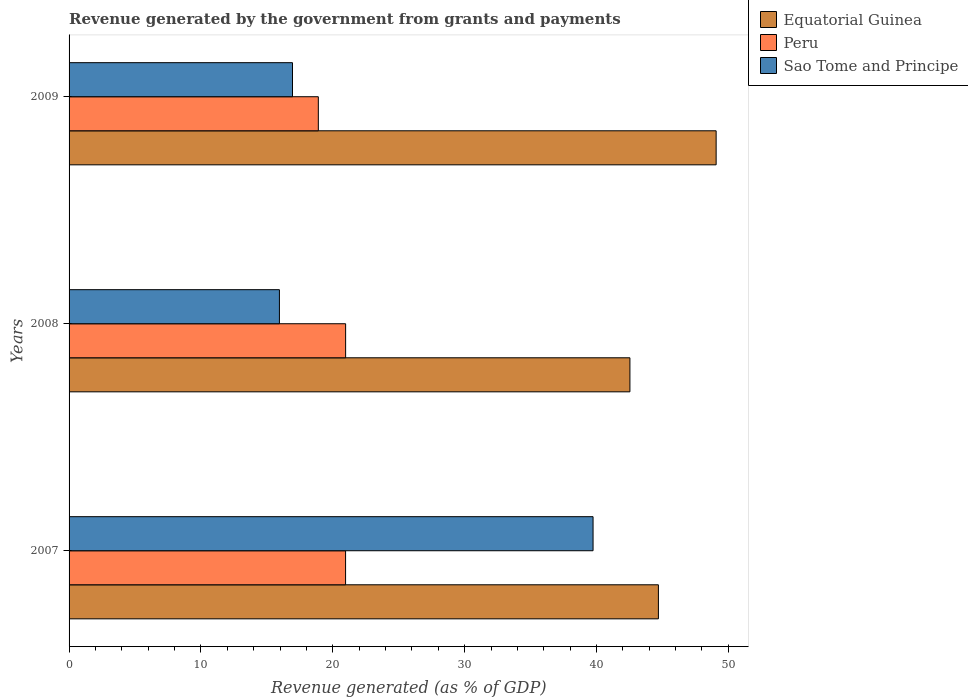Are the number of bars per tick equal to the number of legend labels?
Your answer should be very brief. Yes. How many bars are there on the 2nd tick from the top?
Offer a very short reply. 3. How many bars are there on the 2nd tick from the bottom?
Keep it short and to the point. 3. In how many cases, is the number of bars for a given year not equal to the number of legend labels?
Provide a short and direct response. 0. What is the revenue generated by the government in Equatorial Guinea in 2008?
Your answer should be very brief. 42.54. Across all years, what is the maximum revenue generated by the government in Equatorial Guinea?
Offer a very short reply. 49.07. Across all years, what is the minimum revenue generated by the government in Peru?
Ensure brevity in your answer.  18.9. In which year was the revenue generated by the government in Sao Tome and Principe minimum?
Keep it short and to the point. 2008. What is the total revenue generated by the government in Peru in the graph?
Your answer should be compact. 60.85. What is the difference between the revenue generated by the government in Sao Tome and Principe in 2008 and that in 2009?
Your response must be concise. -0.99. What is the difference between the revenue generated by the government in Peru in 2009 and the revenue generated by the government in Equatorial Guinea in 2007?
Your response must be concise. -25.79. What is the average revenue generated by the government in Sao Tome and Principe per year?
Ensure brevity in your answer.  24.21. In the year 2007, what is the difference between the revenue generated by the government in Peru and revenue generated by the government in Sao Tome and Principe?
Provide a succinct answer. -18.77. In how many years, is the revenue generated by the government in Equatorial Guinea greater than 46 %?
Your answer should be very brief. 1. What is the ratio of the revenue generated by the government in Peru in 2007 to that in 2008?
Your answer should be very brief. 1. Is the difference between the revenue generated by the government in Peru in 2008 and 2009 greater than the difference between the revenue generated by the government in Sao Tome and Principe in 2008 and 2009?
Your response must be concise. Yes. What is the difference between the highest and the second highest revenue generated by the government in Equatorial Guinea?
Your answer should be very brief. 4.38. What is the difference between the highest and the lowest revenue generated by the government in Sao Tome and Principe?
Your response must be concise. 23.79. What does the 1st bar from the top in 2009 represents?
Your answer should be compact. Sao Tome and Principe. How many bars are there?
Offer a very short reply. 9. Are all the bars in the graph horizontal?
Offer a terse response. Yes. How many years are there in the graph?
Your response must be concise. 3. Are the values on the major ticks of X-axis written in scientific E-notation?
Your answer should be very brief. No. Where does the legend appear in the graph?
Your answer should be compact. Top right. How are the legend labels stacked?
Your response must be concise. Vertical. What is the title of the graph?
Your response must be concise. Revenue generated by the government from grants and payments. What is the label or title of the X-axis?
Keep it short and to the point. Revenue generated (as % of GDP). What is the label or title of the Y-axis?
Make the answer very short. Years. What is the Revenue generated (as % of GDP) in Equatorial Guinea in 2007?
Give a very brief answer. 44.7. What is the Revenue generated (as % of GDP) of Peru in 2007?
Provide a succinct answer. 20.97. What is the Revenue generated (as % of GDP) of Sao Tome and Principe in 2007?
Provide a short and direct response. 39.74. What is the Revenue generated (as % of GDP) in Equatorial Guinea in 2008?
Make the answer very short. 42.54. What is the Revenue generated (as % of GDP) of Peru in 2008?
Offer a very short reply. 20.97. What is the Revenue generated (as % of GDP) in Sao Tome and Principe in 2008?
Your answer should be compact. 15.95. What is the Revenue generated (as % of GDP) of Equatorial Guinea in 2009?
Provide a short and direct response. 49.07. What is the Revenue generated (as % of GDP) in Peru in 2009?
Your answer should be compact. 18.9. What is the Revenue generated (as % of GDP) in Sao Tome and Principe in 2009?
Give a very brief answer. 16.95. Across all years, what is the maximum Revenue generated (as % of GDP) in Equatorial Guinea?
Offer a terse response. 49.07. Across all years, what is the maximum Revenue generated (as % of GDP) of Peru?
Make the answer very short. 20.97. Across all years, what is the maximum Revenue generated (as % of GDP) of Sao Tome and Principe?
Your answer should be very brief. 39.74. Across all years, what is the minimum Revenue generated (as % of GDP) of Equatorial Guinea?
Give a very brief answer. 42.54. Across all years, what is the minimum Revenue generated (as % of GDP) in Peru?
Your answer should be very brief. 18.9. Across all years, what is the minimum Revenue generated (as % of GDP) of Sao Tome and Principe?
Offer a terse response. 15.95. What is the total Revenue generated (as % of GDP) in Equatorial Guinea in the graph?
Your response must be concise. 136.31. What is the total Revenue generated (as % of GDP) in Peru in the graph?
Ensure brevity in your answer.  60.85. What is the total Revenue generated (as % of GDP) in Sao Tome and Principe in the graph?
Offer a very short reply. 72.64. What is the difference between the Revenue generated (as % of GDP) of Equatorial Guinea in 2007 and that in 2008?
Keep it short and to the point. 2.16. What is the difference between the Revenue generated (as % of GDP) of Peru in 2007 and that in 2008?
Make the answer very short. -0. What is the difference between the Revenue generated (as % of GDP) in Sao Tome and Principe in 2007 and that in 2008?
Offer a terse response. 23.79. What is the difference between the Revenue generated (as % of GDP) in Equatorial Guinea in 2007 and that in 2009?
Give a very brief answer. -4.38. What is the difference between the Revenue generated (as % of GDP) of Peru in 2007 and that in 2009?
Provide a short and direct response. 2.07. What is the difference between the Revenue generated (as % of GDP) of Sao Tome and Principe in 2007 and that in 2009?
Give a very brief answer. 22.79. What is the difference between the Revenue generated (as % of GDP) of Equatorial Guinea in 2008 and that in 2009?
Your answer should be very brief. -6.54. What is the difference between the Revenue generated (as % of GDP) in Peru in 2008 and that in 2009?
Provide a short and direct response. 2.07. What is the difference between the Revenue generated (as % of GDP) in Sao Tome and Principe in 2008 and that in 2009?
Make the answer very short. -0.99. What is the difference between the Revenue generated (as % of GDP) in Equatorial Guinea in 2007 and the Revenue generated (as % of GDP) in Peru in 2008?
Make the answer very short. 23.72. What is the difference between the Revenue generated (as % of GDP) of Equatorial Guinea in 2007 and the Revenue generated (as % of GDP) of Sao Tome and Principe in 2008?
Ensure brevity in your answer.  28.74. What is the difference between the Revenue generated (as % of GDP) of Peru in 2007 and the Revenue generated (as % of GDP) of Sao Tome and Principe in 2008?
Ensure brevity in your answer.  5.02. What is the difference between the Revenue generated (as % of GDP) in Equatorial Guinea in 2007 and the Revenue generated (as % of GDP) in Peru in 2009?
Give a very brief answer. 25.79. What is the difference between the Revenue generated (as % of GDP) of Equatorial Guinea in 2007 and the Revenue generated (as % of GDP) of Sao Tome and Principe in 2009?
Your response must be concise. 27.75. What is the difference between the Revenue generated (as % of GDP) of Peru in 2007 and the Revenue generated (as % of GDP) of Sao Tome and Principe in 2009?
Your answer should be compact. 4.03. What is the difference between the Revenue generated (as % of GDP) in Equatorial Guinea in 2008 and the Revenue generated (as % of GDP) in Peru in 2009?
Your answer should be very brief. 23.63. What is the difference between the Revenue generated (as % of GDP) of Equatorial Guinea in 2008 and the Revenue generated (as % of GDP) of Sao Tome and Principe in 2009?
Your answer should be very brief. 25.59. What is the difference between the Revenue generated (as % of GDP) in Peru in 2008 and the Revenue generated (as % of GDP) in Sao Tome and Principe in 2009?
Ensure brevity in your answer.  4.03. What is the average Revenue generated (as % of GDP) of Equatorial Guinea per year?
Provide a short and direct response. 45.44. What is the average Revenue generated (as % of GDP) of Peru per year?
Provide a succinct answer. 20.28. What is the average Revenue generated (as % of GDP) in Sao Tome and Principe per year?
Provide a short and direct response. 24.21. In the year 2007, what is the difference between the Revenue generated (as % of GDP) in Equatorial Guinea and Revenue generated (as % of GDP) in Peru?
Your answer should be compact. 23.73. In the year 2007, what is the difference between the Revenue generated (as % of GDP) in Equatorial Guinea and Revenue generated (as % of GDP) in Sao Tome and Principe?
Give a very brief answer. 4.96. In the year 2007, what is the difference between the Revenue generated (as % of GDP) in Peru and Revenue generated (as % of GDP) in Sao Tome and Principe?
Your answer should be very brief. -18.77. In the year 2008, what is the difference between the Revenue generated (as % of GDP) of Equatorial Guinea and Revenue generated (as % of GDP) of Peru?
Provide a short and direct response. 21.56. In the year 2008, what is the difference between the Revenue generated (as % of GDP) in Equatorial Guinea and Revenue generated (as % of GDP) in Sao Tome and Principe?
Your answer should be compact. 26.58. In the year 2008, what is the difference between the Revenue generated (as % of GDP) in Peru and Revenue generated (as % of GDP) in Sao Tome and Principe?
Ensure brevity in your answer.  5.02. In the year 2009, what is the difference between the Revenue generated (as % of GDP) in Equatorial Guinea and Revenue generated (as % of GDP) in Peru?
Offer a very short reply. 30.17. In the year 2009, what is the difference between the Revenue generated (as % of GDP) in Equatorial Guinea and Revenue generated (as % of GDP) in Sao Tome and Principe?
Make the answer very short. 32.13. In the year 2009, what is the difference between the Revenue generated (as % of GDP) of Peru and Revenue generated (as % of GDP) of Sao Tome and Principe?
Your answer should be compact. 1.96. What is the ratio of the Revenue generated (as % of GDP) of Equatorial Guinea in 2007 to that in 2008?
Offer a very short reply. 1.05. What is the ratio of the Revenue generated (as % of GDP) in Peru in 2007 to that in 2008?
Your response must be concise. 1. What is the ratio of the Revenue generated (as % of GDP) in Sao Tome and Principe in 2007 to that in 2008?
Your answer should be compact. 2.49. What is the ratio of the Revenue generated (as % of GDP) of Equatorial Guinea in 2007 to that in 2009?
Offer a very short reply. 0.91. What is the ratio of the Revenue generated (as % of GDP) in Peru in 2007 to that in 2009?
Provide a short and direct response. 1.11. What is the ratio of the Revenue generated (as % of GDP) of Sao Tome and Principe in 2007 to that in 2009?
Offer a terse response. 2.35. What is the ratio of the Revenue generated (as % of GDP) in Equatorial Guinea in 2008 to that in 2009?
Your response must be concise. 0.87. What is the ratio of the Revenue generated (as % of GDP) in Peru in 2008 to that in 2009?
Offer a very short reply. 1.11. What is the ratio of the Revenue generated (as % of GDP) in Sao Tome and Principe in 2008 to that in 2009?
Provide a short and direct response. 0.94. What is the difference between the highest and the second highest Revenue generated (as % of GDP) in Equatorial Guinea?
Your response must be concise. 4.38. What is the difference between the highest and the second highest Revenue generated (as % of GDP) in Peru?
Your answer should be compact. 0. What is the difference between the highest and the second highest Revenue generated (as % of GDP) in Sao Tome and Principe?
Provide a succinct answer. 22.79. What is the difference between the highest and the lowest Revenue generated (as % of GDP) in Equatorial Guinea?
Offer a terse response. 6.54. What is the difference between the highest and the lowest Revenue generated (as % of GDP) of Peru?
Ensure brevity in your answer.  2.07. What is the difference between the highest and the lowest Revenue generated (as % of GDP) in Sao Tome and Principe?
Offer a terse response. 23.79. 